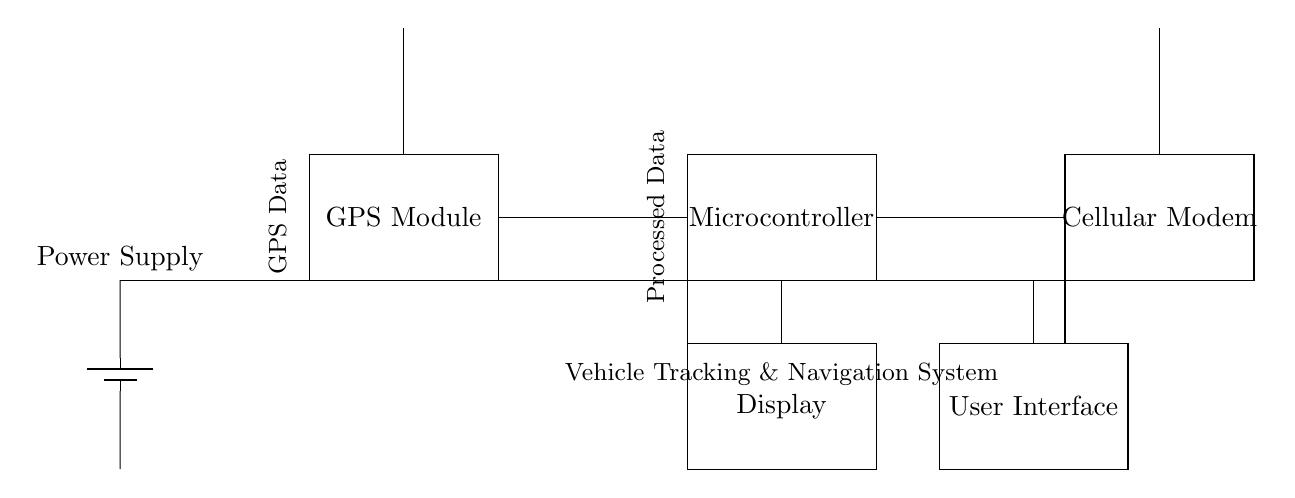What are the main components of this circuit? The circuit includes a GPS Module, Microcontroller, Cellular Modem, Power Supply, Display, and User Interface. Each of these elements is represented as rectangles in the diagram, indicating they are separate components in the system.
Answer: GPS Module, Microcontroller, Cellular Modem, Power Supply, Display, User Interface What does the Power Supply connect to? The Power Supply connects to the GPS Module, Microcontroller, and Cellular Modem, as evidenced by the connections drawn from it to each of these components. These connections ensure that each component receives the necessary power to operate.
Answer: GPS Module, Microcontroller, Cellular Modem What type of data does the GPS module provide? The GPS Module provides GPS Data, as indicated by the label placed next to it in the circuit diagram. The label shows this is its primary function within the overall system.
Answer: GPS Data How does the Microcontroller interact with the Cellular Modem? The Microcontroller processes the data received from the GPS Module and sends the processed data to the Cellular Modem. This relationship is depicted with a direct line connecting the two components, implying data flow from the Microcontroller to the Cellular Modem.
Answer: Processes data and sends to it How many antennas are shown in the circuit diagram? There are two antennas represented in the diagram, one associated with the GPS Module and another with the Cellular Modem. The presence of these two components indicates their importance for tracking and communication functionalities in fleet management.
Answer: Two What is the purpose of the Display in this circuit? The Display shows processed information for the user, making it an interface for interaction with the system. It is connected to the Microcontroller, which sends the relevant information to be displayed. This suggests it plays a crucial role in user feedback.
Answer: User feedback interface 